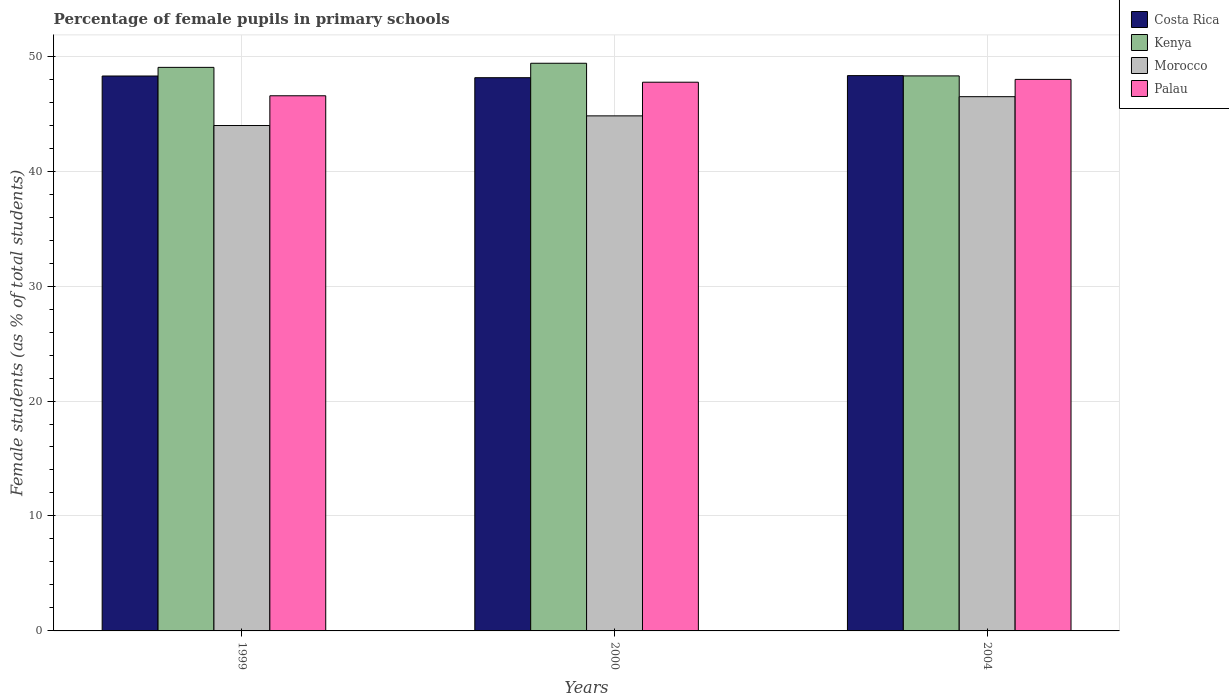How many groups of bars are there?
Your response must be concise. 3. Are the number of bars on each tick of the X-axis equal?
Ensure brevity in your answer.  Yes. How many bars are there on the 1st tick from the left?
Your answer should be compact. 4. What is the label of the 2nd group of bars from the left?
Ensure brevity in your answer.  2000. In how many cases, is the number of bars for a given year not equal to the number of legend labels?
Your response must be concise. 0. What is the percentage of female pupils in primary schools in Kenya in 2004?
Your answer should be compact. 48.28. Across all years, what is the maximum percentage of female pupils in primary schools in Kenya?
Your response must be concise. 49.38. Across all years, what is the minimum percentage of female pupils in primary schools in Kenya?
Ensure brevity in your answer.  48.28. In which year was the percentage of female pupils in primary schools in Kenya maximum?
Offer a very short reply. 2000. What is the total percentage of female pupils in primary schools in Kenya in the graph?
Provide a short and direct response. 146.69. What is the difference between the percentage of female pupils in primary schools in Morocco in 1999 and that in 2000?
Your response must be concise. -0.84. What is the difference between the percentage of female pupils in primary schools in Costa Rica in 2000 and the percentage of female pupils in primary schools in Morocco in 1999?
Make the answer very short. 4.16. What is the average percentage of female pupils in primary schools in Costa Rica per year?
Your response must be concise. 48.24. In the year 1999, what is the difference between the percentage of female pupils in primary schools in Palau and percentage of female pupils in primary schools in Kenya?
Offer a very short reply. -2.47. What is the ratio of the percentage of female pupils in primary schools in Morocco in 1999 to that in 2000?
Provide a succinct answer. 0.98. Is the difference between the percentage of female pupils in primary schools in Palau in 1999 and 2000 greater than the difference between the percentage of female pupils in primary schools in Kenya in 1999 and 2000?
Provide a short and direct response. No. What is the difference between the highest and the second highest percentage of female pupils in primary schools in Costa Rica?
Offer a very short reply. 0.03. What is the difference between the highest and the lowest percentage of female pupils in primary schools in Costa Rica?
Offer a very short reply. 0.18. In how many years, is the percentage of female pupils in primary schools in Costa Rica greater than the average percentage of female pupils in primary schools in Costa Rica taken over all years?
Offer a very short reply. 2. Is it the case that in every year, the sum of the percentage of female pupils in primary schools in Morocco and percentage of female pupils in primary schools in Palau is greater than the sum of percentage of female pupils in primary schools in Costa Rica and percentage of female pupils in primary schools in Kenya?
Offer a terse response. No. What does the 4th bar from the left in 2000 represents?
Your response must be concise. Palau. What does the 1st bar from the right in 1999 represents?
Your response must be concise. Palau. Is it the case that in every year, the sum of the percentage of female pupils in primary schools in Costa Rica and percentage of female pupils in primary schools in Palau is greater than the percentage of female pupils in primary schools in Kenya?
Ensure brevity in your answer.  Yes. How many years are there in the graph?
Your response must be concise. 3. What is the difference between two consecutive major ticks on the Y-axis?
Make the answer very short. 10. Does the graph contain any zero values?
Give a very brief answer. No. Where does the legend appear in the graph?
Your answer should be very brief. Top right. How are the legend labels stacked?
Your answer should be very brief. Vertical. What is the title of the graph?
Provide a succinct answer. Percentage of female pupils in primary schools. What is the label or title of the Y-axis?
Your response must be concise. Female students (as % of total students). What is the Female students (as % of total students) of Costa Rica in 1999?
Offer a terse response. 48.27. What is the Female students (as % of total students) in Kenya in 1999?
Provide a short and direct response. 49.03. What is the Female students (as % of total students) in Morocco in 1999?
Offer a terse response. 43.97. What is the Female students (as % of total students) of Palau in 1999?
Ensure brevity in your answer.  46.55. What is the Female students (as % of total students) of Costa Rica in 2000?
Ensure brevity in your answer.  48.13. What is the Female students (as % of total students) of Kenya in 2000?
Provide a short and direct response. 49.38. What is the Female students (as % of total students) of Morocco in 2000?
Provide a succinct answer. 44.81. What is the Female students (as % of total students) of Palau in 2000?
Provide a short and direct response. 47.73. What is the Female students (as % of total students) of Costa Rica in 2004?
Your response must be concise. 48.31. What is the Female students (as % of total students) in Kenya in 2004?
Your response must be concise. 48.28. What is the Female students (as % of total students) of Morocco in 2004?
Provide a succinct answer. 46.48. What is the Female students (as % of total students) of Palau in 2004?
Your answer should be very brief. 47.98. Across all years, what is the maximum Female students (as % of total students) in Costa Rica?
Offer a terse response. 48.31. Across all years, what is the maximum Female students (as % of total students) in Kenya?
Keep it short and to the point. 49.38. Across all years, what is the maximum Female students (as % of total students) in Morocco?
Offer a very short reply. 46.48. Across all years, what is the maximum Female students (as % of total students) of Palau?
Offer a very short reply. 47.98. Across all years, what is the minimum Female students (as % of total students) in Costa Rica?
Offer a very short reply. 48.13. Across all years, what is the minimum Female students (as % of total students) in Kenya?
Provide a short and direct response. 48.28. Across all years, what is the minimum Female students (as % of total students) of Morocco?
Offer a very short reply. 43.97. Across all years, what is the minimum Female students (as % of total students) of Palau?
Ensure brevity in your answer.  46.55. What is the total Female students (as % of total students) of Costa Rica in the graph?
Provide a succinct answer. 144.71. What is the total Female students (as % of total students) of Kenya in the graph?
Ensure brevity in your answer.  146.69. What is the total Female students (as % of total students) of Morocco in the graph?
Your answer should be compact. 135.25. What is the total Female students (as % of total students) in Palau in the graph?
Offer a very short reply. 142.27. What is the difference between the Female students (as % of total students) of Costa Rica in 1999 and that in 2000?
Provide a short and direct response. 0.15. What is the difference between the Female students (as % of total students) in Kenya in 1999 and that in 2000?
Provide a short and direct response. -0.36. What is the difference between the Female students (as % of total students) in Morocco in 1999 and that in 2000?
Give a very brief answer. -0.84. What is the difference between the Female students (as % of total students) of Palau in 1999 and that in 2000?
Ensure brevity in your answer.  -1.18. What is the difference between the Female students (as % of total students) in Costa Rica in 1999 and that in 2004?
Your answer should be very brief. -0.03. What is the difference between the Female students (as % of total students) in Kenya in 1999 and that in 2004?
Provide a succinct answer. 0.74. What is the difference between the Female students (as % of total students) of Morocco in 1999 and that in 2004?
Offer a very short reply. -2.51. What is the difference between the Female students (as % of total students) in Palau in 1999 and that in 2004?
Offer a terse response. -1.42. What is the difference between the Female students (as % of total students) in Costa Rica in 2000 and that in 2004?
Give a very brief answer. -0.18. What is the difference between the Female students (as % of total students) of Kenya in 2000 and that in 2004?
Provide a short and direct response. 1.1. What is the difference between the Female students (as % of total students) of Morocco in 2000 and that in 2004?
Offer a very short reply. -1.67. What is the difference between the Female students (as % of total students) in Palau in 2000 and that in 2004?
Your answer should be very brief. -0.24. What is the difference between the Female students (as % of total students) of Costa Rica in 1999 and the Female students (as % of total students) of Kenya in 2000?
Provide a short and direct response. -1.11. What is the difference between the Female students (as % of total students) of Costa Rica in 1999 and the Female students (as % of total students) of Morocco in 2000?
Make the answer very short. 3.47. What is the difference between the Female students (as % of total students) in Costa Rica in 1999 and the Female students (as % of total students) in Palau in 2000?
Your response must be concise. 0.54. What is the difference between the Female students (as % of total students) in Kenya in 1999 and the Female students (as % of total students) in Morocco in 2000?
Your answer should be very brief. 4.22. What is the difference between the Female students (as % of total students) in Kenya in 1999 and the Female students (as % of total students) in Palau in 2000?
Offer a terse response. 1.29. What is the difference between the Female students (as % of total students) of Morocco in 1999 and the Female students (as % of total students) of Palau in 2000?
Provide a succinct answer. -3.77. What is the difference between the Female students (as % of total students) of Costa Rica in 1999 and the Female students (as % of total students) of Kenya in 2004?
Offer a very short reply. -0.01. What is the difference between the Female students (as % of total students) in Costa Rica in 1999 and the Female students (as % of total students) in Morocco in 2004?
Provide a short and direct response. 1.8. What is the difference between the Female students (as % of total students) of Costa Rica in 1999 and the Female students (as % of total students) of Palau in 2004?
Offer a terse response. 0.3. What is the difference between the Female students (as % of total students) of Kenya in 1999 and the Female students (as % of total students) of Morocco in 2004?
Ensure brevity in your answer.  2.55. What is the difference between the Female students (as % of total students) in Kenya in 1999 and the Female students (as % of total students) in Palau in 2004?
Your answer should be very brief. 1.05. What is the difference between the Female students (as % of total students) in Morocco in 1999 and the Female students (as % of total students) in Palau in 2004?
Your response must be concise. -4.01. What is the difference between the Female students (as % of total students) of Costa Rica in 2000 and the Female students (as % of total students) of Kenya in 2004?
Give a very brief answer. -0.16. What is the difference between the Female students (as % of total students) of Costa Rica in 2000 and the Female students (as % of total students) of Morocco in 2004?
Your answer should be compact. 1.65. What is the difference between the Female students (as % of total students) of Costa Rica in 2000 and the Female students (as % of total students) of Palau in 2004?
Keep it short and to the point. 0.15. What is the difference between the Female students (as % of total students) in Kenya in 2000 and the Female students (as % of total students) in Morocco in 2004?
Provide a short and direct response. 2.91. What is the difference between the Female students (as % of total students) of Kenya in 2000 and the Female students (as % of total students) of Palau in 2004?
Provide a succinct answer. 1.4. What is the difference between the Female students (as % of total students) in Morocco in 2000 and the Female students (as % of total students) in Palau in 2004?
Offer a terse response. -3.17. What is the average Female students (as % of total students) of Costa Rica per year?
Your response must be concise. 48.24. What is the average Female students (as % of total students) of Kenya per year?
Offer a terse response. 48.9. What is the average Female students (as % of total students) of Morocco per year?
Your answer should be very brief. 45.08. What is the average Female students (as % of total students) in Palau per year?
Your answer should be compact. 47.42. In the year 1999, what is the difference between the Female students (as % of total students) in Costa Rica and Female students (as % of total students) in Kenya?
Ensure brevity in your answer.  -0.75. In the year 1999, what is the difference between the Female students (as % of total students) in Costa Rica and Female students (as % of total students) in Morocco?
Offer a terse response. 4.31. In the year 1999, what is the difference between the Female students (as % of total students) of Costa Rica and Female students (as % of total students) of Palau?
Provide a short and direct response. 1.72. In the year 1999, what is the difference between the Female students (as % of total students) in Kenya and Female students (as % of total students) in Morocco?
Provide a succinct answer. 5.06. In the year 1999, what is the difference between the Female students (as % of total students) of Kenya and Female students (as % of total students) of Palau?
Your response must be concise. 2.47. In the year 1999, what is the difference between the Female students (as % of total students) of Morocco and Female students (as % of total students) of Palau?
Your response must be concise. -2.59. In the year 2000, what is the difference between the Female students (as % of total students) of Costa Rica and Female students (as % of total students) of Kenya?
Your answer should be compact. -1.26. In the year 2000, what is the difference between the Female students (as % of total students) of Costa Rica and Female students (as % of total students) of Morocco?
Your response must be concise. 3.32. In the year 2000, what is the difference between the Female students (as % of total students) in Costa Rica and Female students (as % of total students) in Palau?
Keep it short and to the point. 0.39. In the year 2000, what is the difference between the Female students (as % of total students) of Kenya and Female students (as % of total students) of Morocco?
Ensure brevity in your answer.  4.58. In the year 2000, what is the difference between the Female students (as % of total students) in Kenya and Female students (as % of total students) in Palau?
Your answer should be compact. 1.65. In the year 2000, what is the difference between the Female students (as % of total students) in Morocco and Female students (as % of total students) in Palau?
Your response must be concise. -2.93. In the year 2004, what is the difference between the Female students (as % of total students) of Costa Rica and Female students (as % of total students) of Kenya?
Ensure brevity in your answer.  0.03. In the year 2004, what is the difference between the Female students (as % of total students) of Costa Rica and Female students (as % of total students) of Morocco?
Offer a terse response. 1.83. In the year 2004, what is the difference between the Female students (as % of total students) in Costa Rica and Female students (as % of total students) in Palau?
Give a very brief answer. 0.33. In the year 2004, what is the difference between the Female students (as % of total students) in Kenya and Female students (as % of total students) in Morocco?
Your response must be concise. 1.81. In the year 2004, what is the difference between the Female students (as % of total students) in Kenya and Female students (as % of total students) in Palau?
Your answer should be compact. 0.3. In the year 2004, what is the difference between the Female students (as % of total students) of Morocco and Female students (as % of total students) of Palau?
Provide a short and direct response. -1.5. What is the ratio of the Female students (as % of total students) in Morocco in 1999 to that in 2000?
Give a very brief answer. 0.98. What is the ratio of the Female students (as % of total students) of Palau in 1999 to that in 2000?
Your answer should be very brief. 0.98. What is the ratio of the Female students (as % of total students) of Costa Rica in 1999 to that in 2004?
Your answer should be compact. 1. What is the ratio of the Female students (as % of total students) in Kenya in 1999 to that in 2004?
Offer a very short reply. 1.02. What is the ratio of the Female students (as % of total students) of Morocco in 1999 to that in 2004?
Keep it short and to the point. 0.95. What is the ratio of the Female students (as % of total students) of Palau in 1999 to that in 2004?
Offer a very short reply. 0.97. What is the ratio of the Female students (as % of total students) in Kenya in 2000 to that in 2004?
Offer a very short reply. 1.02. What is the ratio of the Female students (as % of total students) of Morocco in 2000 to that in 2004?
Offer a very short reply. 0.96. What is the ratio of the Female students (as % of total students) of Palau in 2000 to that in 2004?
Offer a terse response. 0.99. What is the difference between the highest and the second highest Female students (as % of total students) of Costa Rica?
Ensure brevity in your answer.  0.03. What is the difference between the highest and the second highest Female students (as % of total students) in Kenya?
Your response must be concise. 0.36. What is the difference between the highest and the second highest Female students (as % of total students) of Morocco?
Give a very brief answer. 1.67. What is the difference between the highest and the second highest Female students (as % of total students) of Palau?
Keep it short and to the point. 0.24. What is the difference between the highest and the lowest Female students (as % of total students) of Costa Rica?
Offer a terse response. 0.18. What is the difference between the highest and the lowest Female students (as % of total students) of Kenya?
Offer a terse response. 1.1. What is the difference between the highest and the lowest Female students (as % of total students) in Morocco?
Your answer should be compact. 2.51. What is the difference between the highest and the lowest Female students (as % of total students) of Palau?
Provide a succinct answer. 1.42. 